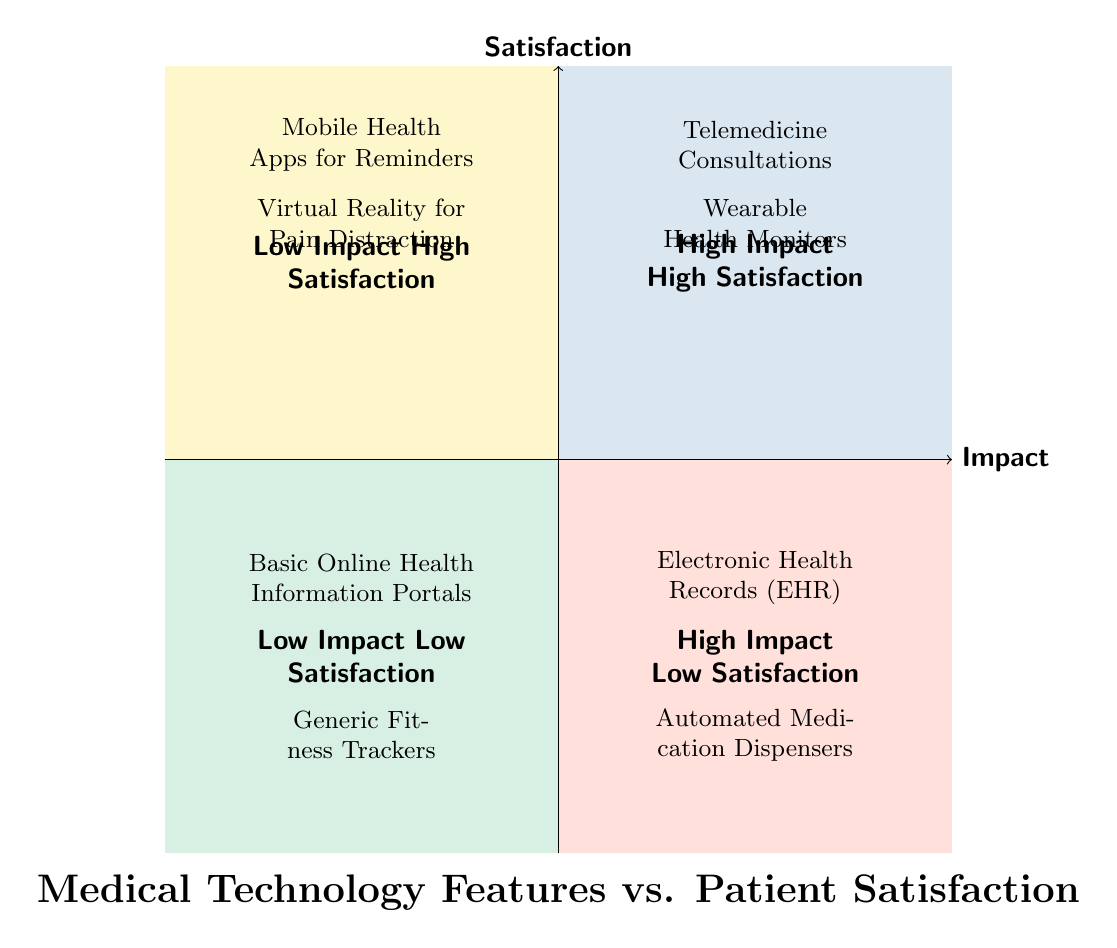What features are located in the High Impact High Satisfaction quadrant? The High Impact High Satisfaction quadrant is identified in the top right section of the diagram. The features listed in this quadrant are "Telemedicine Consultations" and "Wearable Health Monitors" based on their impact on patients and the satisfaction they provide.
Answer: Telemedicine Consultations, Wearable Health Monitors How many features are categorized under Low Impact Low Satisfaction? The Low Impact Low Satisfaction quadrant is located in the bottom left section of the diagram. It contains two features: "Basic Online Health Information Portals" and "Generic Fitness Trackers." Thus, when counting these features, we find there are two.
Answer: 2 Which feature has a high impact but low satisfaction? The quadrant depicting High Impact Low Satisfaction is located in the bottom right section of the diagram. Within that section, the features listed are "Electronic Health Records (EHR)" and "Automated Medication Dispensers." Thus, one example of a feature with high impact and low satisfaction is "Electronic Health Records (EHR)."
Answer: Electronic Health Records (EHR) What is the primary source of satisfaction for Wearable Health Monitors? To find the source of satisfaction associated with the "Wearable Health Monitors," we observe its description in the High Impact High Satisfaction quadrant. The description states it provides "Continuous monitoring of vital signs and early detection of health deterioration," which directly contributes to patient satisfaction.
Answer: Continuous monitoring of vital signs and early detection of health deterioration Which quadrant contains Mobile Health Apps for Reminders and what is its impact and satisfaction level? The "Mobile Health Apps for Reminders" feature is located in the Low Impact High Satisfaction quadrant, which is positioned in the top left section of the diagram. It is categorized as low impact because it does not critically change health outcomes but is associated with high patient satisfaction due to its usability.
Answer: Low Impact High Satisfaction Are there any features with both low impact and high satisfaction? Yes, when looking at the Low Impact High Satisfaction quadrant, specifically in the bottom left section, we can confirm the presence of features that fall into this category. These features are important despite their lower impact on health outcomes.
Answer: Yes 